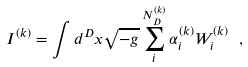Convert formula to latex. <formula><loc_0><loc_0><loc_500><loc_500>I ^ { ( k ) } = \int d ^ { D } x \sqrt { - g } \sum _ { i } ^ { N _ { D } ^ { ( k ) } } \alpha _ { i } ^ { ( k ) } W _ { i } ^ { ( k ) } \ ,</formula> 